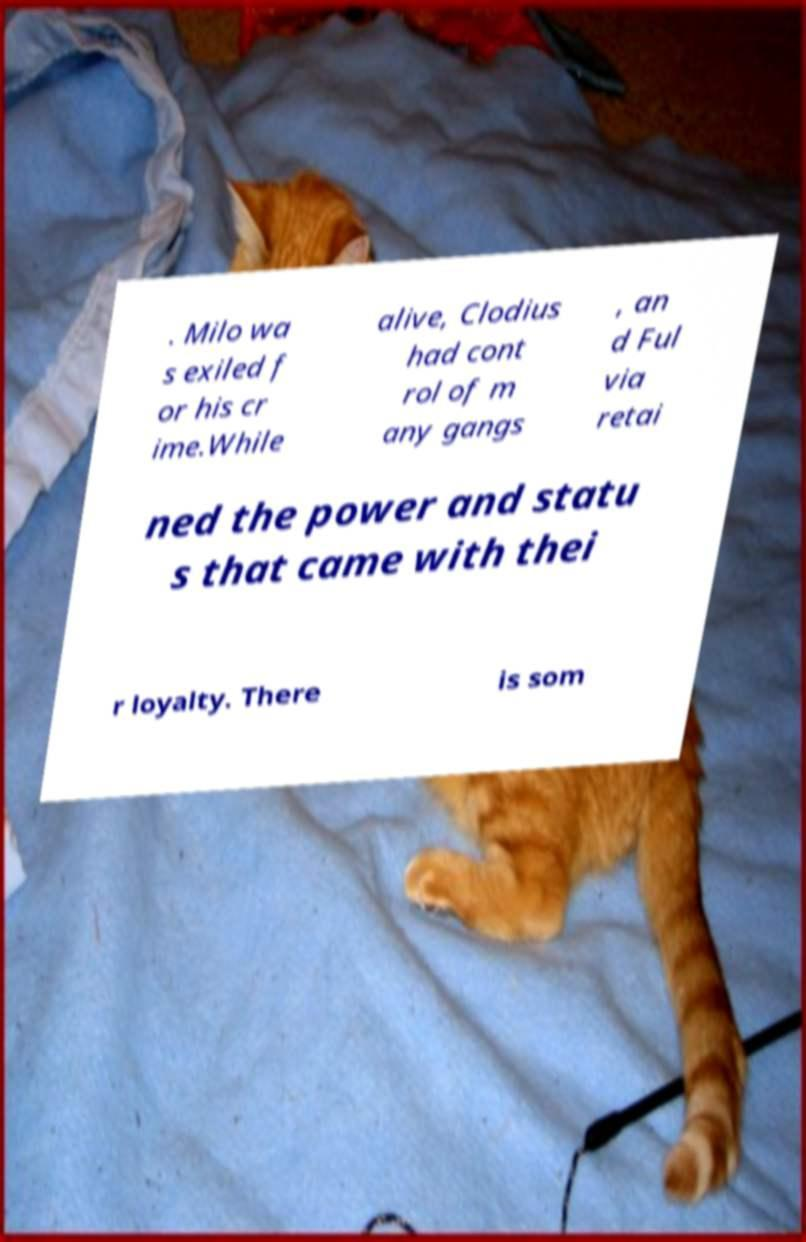Please read and relay the text visible in this image. What does it say? . Milo wa s exiled f or his cr ime.While alive, Clodius had cont rol of m any gangs , an d Ful via retai ned the power and statu s that came with thei r loyalty. There is som 